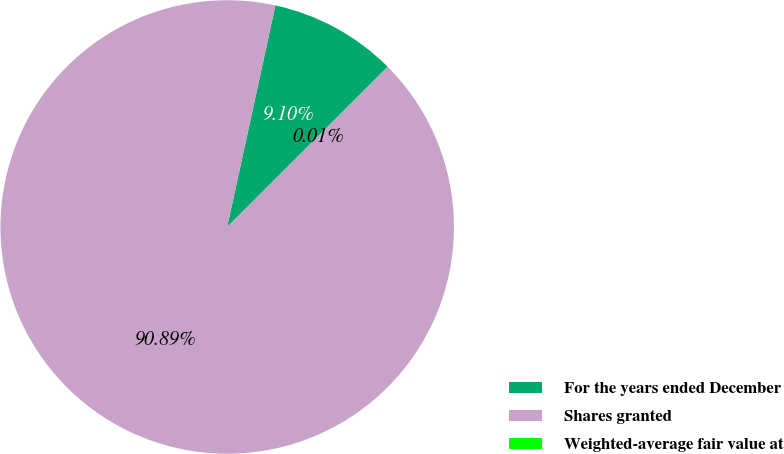Convert chart to OTSL. <chart><loc_0><loc_0><loc_500><loc_500><pie_chart><fcel>For the years ended December<fcel>Shares granted<fcel>Weighted-average fair value at<nl><fcel>9.1%<fcel>90.89%<fcel>0.01%<nl></chart> 